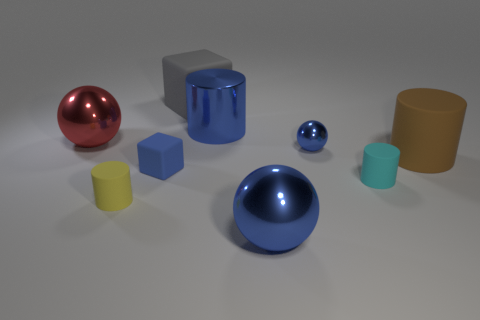Is there another large shiny object of the same shape as the brown thing?
Offer a very short reply. Yes. There is a yellow cylinder that is in front of the tiny metallic ball; is it the same size as the rubber cube in front of the gray object?
Your response must be concise. Yes. There is a brown matte thing that is to the right of the sphere that is to the left of the tiny yellow thing; what shape is it?
Your answer should be compact. Cylinder. How many blue objects have the same size as the brown rubber object?
Ensure brevity in your answer.  2. Is there a blue sphere?
Offer a terse response. Yes. Are there any other things that are the same color as the big cube?
Keep it short and to the point. No. There is a big gray object that is the same material as the small cyan cylinder; what is its shape?
Provide a short and direct response. Cube. There is a sphere that is on the right side of the big blue thing that is in front of the small rubber cylinder right of the tiny matte block; what is its color?
Offer a very short reply. Blue. Is the number of big matte cubes behind the big red shiny object the same as the number of yellow matte cylinders?
Provide a succinct answer. Yes. There is a tiny rubber block; does it have the same color as the ball that is in front of the tiny yellow cylinder?
Offer a very short reply. Yes. 